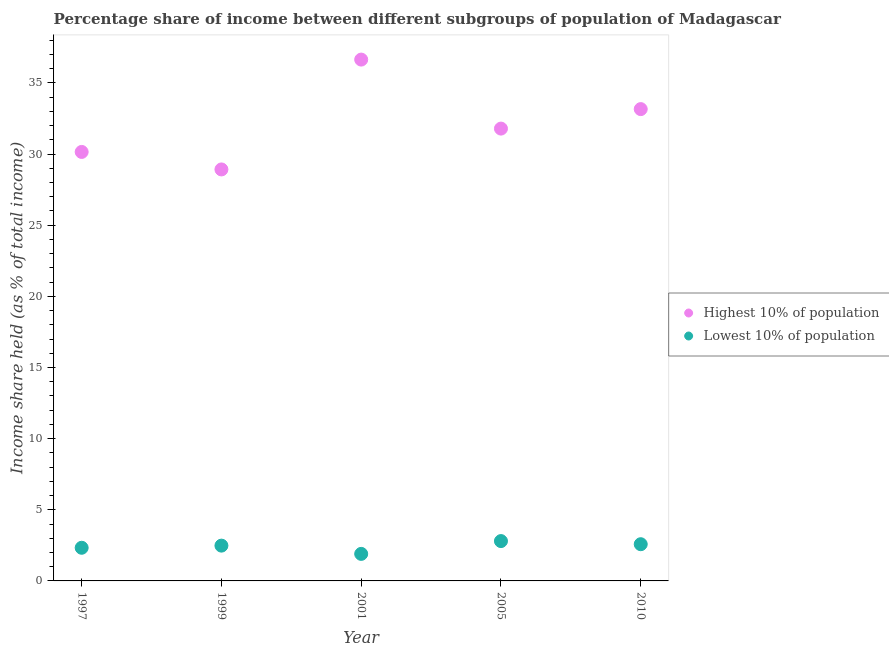What is the income share held by lowest 10% of the population in 1999?
Keep it short and to the point. 2.48. Across all years, what is the maximum income share held by highest 10% of the population?
Give a very brief answer. 36.64. Across all years, what is the minimum income share held by lowest 10% of the population?
Offer a terse response. 1.9. What is the total income share held by highest 10% of the population in the graph?
Give a very brief answer. 160.66. What is the difference between the income share held by highest 10% of the population in 2001 and that in 2005?
Give a very brief answer. 4.85. What is the difference between the income share held by lowest 10% of the population in 1997 and the income share held by highest 10% of the population in 2005?
Offer a terse response. -29.46. What is the average income share held by highest 10% of the population per year?
Provide a succinct answer. 32.13. In the year 1999, what is the difference between the income share held by highest 10% of the population and income share held by lowest 10% of the population?
Provide a short and direct response. 26.44. In how many years, is the income share held by highest 10% of the population greater than 32 %?
Your answer should be compact. 2. What is the ratio of the income share held by lowest 10% of the population in 1999 to that in 2010?
Your answer should be compact. 0.96. Is the income share held by highest 10% of the population in 1997 less than that in 2005?
Your answer should be very brief. Yes. What is the difference between the highest and the second highest income share held by highest 10% of the population?
Your answer should be compact. 3.48. What is the difference between the highest and the lowest income share held by highest 10% of the population?
Offer a very short reply. 7.72. Is the sum of the income share held by lowest 10% of the population in 1999 and 2005 greater than the maximum income share held by highest 10% of the population across all years?
Provide a short and direct response. No. Is the income share held by lowest 10% of the population strictly less than the income share held by highest 10% of the population over the years?
Provide a short and direct response. Yes. How many dotlines are there?
Provide a short and direct response. 2. What is the difference between two consecutive major ticks on the Y-axis?
Make the answer very short. 5. Are the values on the major ticks of Y-axis written in scientific E-notation?
Your answer should be very brief. No. Does the graph contain any zero values?
Give a very brief answer. No. How many legend labels are there?
Provide a short and direct response. 2. How are the legend labels stacked?
Provide a short and direct response. Vertical. What is the title of the graph?
Provide a short and direct response. Percentage share of income between different subgroups of population of Madagascar. Does "Official aid received" appear as one of the legend labels in the graph?
Provide a succinct answer. No. What is the label or title of the Y-axis?
Your answer should be compact. Income share held (as % of total income). What is the Income share held (as % of total income) of Highest 10% of population in 1997?
Keep it short and to the point. 30.15. What is the Income share held (as % of total income) of Lowest 10% of population in 1997?
Make the answer very short. 2.33. What is the Income share held (as % of total income) of Highest 10% of population in 1999?
Give a very brief answer. 28.92. What is the Income share held (as % of total income) in Lowest 10% of population in 1999?
Ensure brevity in your answer.  2.48. What is the Income share held (as % of total income) of Highest 10% of population in 2001?
Give a very brief answer. 36.64. What is the Income share held (as % of total income) in Highest 10% of population in 2005?
Offer a terse response. 31.79. What is the Income share held (as % of total income) of Highest 10% of population in 2010?
Give a very brief answer. 33.16. What is the Income share held (as % of total income) in Lowest 10% of population in 2010?
Your response must be concise. 2.58. Across all years, what is the maximum Income share held (as % of total income) of Highest 10% of population?
Offer a very short reply. 36.64. Across all years, what is the minimum Income share held (as % of total income) of Highest 10% of population?
Provide a short and direct response. 28.92. What is the total Income share held (as % of total income) in Highest 10% of population in the graph?
Your response must be concise. 160.66. What is the total Income share held (as % of total income) in Lowest 10% of population in the graph?
Ensure brevity in your answer.  12.09. What is the difference between the Income share held (as % of total income) in Highest 10% of population in 1997 and that in 1999?
Make the answer very short. 1.23. What is the difference between the Income share held (as % of total income) of Highest 10% of population in 1997 and that in 2001?
Keep it short and to the point. -6.49. What is the difference between the Income share held (as % of total income) in Lowest 10% of population in 1997 and that in 2001?
Your response must be concise. 0.43. What is the difference between the Income share held (as % of total income) of Highest 10% of population in 1997 and that in 2005?
Ensure brevity in your answer.  -1.64. What is the difference between the Income share held (as % of total income) of Lowest 10% of population in 1997 and that in 2005?
Offer a terse response. -0.47. What is the difference between the Income share held (as % of total income) in Highest 10% of population in 1997 and that in 2010?
Make the answer very short. -3.01. What is the difference between the Income share held (as % of total income) in Lowest 10% of population in 1997 and that in 2010?
Offer a very short reply. -0.25. What is the difference between the Income share held (as % of total income) of Highest 10% of population in 1999 and that in 2001?
Give a very brief answer. -7.72. What is the difference between the Income share held (as % of total income) of Lowest 10% of population in 1999 and that in 2001?
Keep it short and to the point. 0.58. What is the difference between the Income share held (as % of total income) of Highest 10% of population in 1999 and that in 2005?
Provide a succinct answer. -2.87. What is the difference between the Income share held (as % of total income) of Lowest 10% of population in 1999 and that in 2005?
Offer a very short reply. -0.32. What is the difference between the Income share held (as % of total income) in Highest 10% of population in 1999 and that in 2010?
Your answer should be very brief. -4.24. What is the difference between the Income share held (as % of total income) of Lowest 10% of population in 1999 and that in 2010?
Give a very brief answer. -0.1. What is the difference between the Income share held (as % of total income) of Highest 10% of population in 2001 and that in 2005?
Provide a short and direct response. 4.85. What is the difference between the Income share held (as % of total income) in Highest 10% of population in 2001 and that in 2010?
Offer a very short reply. 3.48. What is the difference between the Income share held (as % of total income) in Lowest 10% of population in 2001 and that in 2010?
Offer a very short reply. -0.68. What is the difference between the Income share held (as % of total income) of Highest 10% of population in 2005 and that in 2010?
Your answer should be very brief. -1.37. What is the difference between the Income share held (as % of total income) in Lowest 10% of population in 2005 and that in 2010?
Your answer should be compact. 0.22. What is the difference between the Income share held (as % of total income) in Highest 10% of population in 1997 and the Income share held (as % of total income) in Lowest 10% of population in 1999?
Offer a terse response. 27.67. What is the difference between the Income share held (as % of total income) of Highest 10% of population in 1997 and the Income share held (as % of total income) of Lowest 10% of population in 2001?
Give a very brief answer. 28.25. What is the difference between the Income share held (as % of total income) in Highest 10% of population in 1997 and the Income share held (as % of total income) in Lowest 10% of population in 2005?
Make the answer very short. 27.35. What is the difference between the Income share held (as % of total income) in Highest 10% of population in 1997 and the Income share held (as % of total income) in Lowest 10% of population in 2010?
Give a very brief answer. 27.57. What is the difference between the Income share held (as % of total income) of Highest 10% of population in 1999 and the Income share held (as % of total income) of Lowest 10% of population in 2001?
Ensure brevity in your answer.  27.02. What is the difference between the Income share held (as % of total income) of Highest 10% of population in 1999 and the Income share held (as % of total income) of Lowest 10% of population in 2005?
Give a very brief answer. 26.12. What is the difference between the Income share held (as % of total income) in Highest 10% of population in 1999 and the Income share held (as % of total income) in Lowest 10% of population in 2010?
Provide a succinct answer. 26.34. What is the difference between the Income share held (as % of total income) of Highest 10% of population in 2001 and the Income share held (as % of total income) of Lowest 10% of population in 2005?
Give a very brief answer. 33.84. What is the difference between the Income share held (as % of total income) in Highest 10% of population in 2001 and the Income share held (as % of total income) in Lowest 10% of population in 2010?
Offer a very short reply. 34.06. What is the difference between the Income share held (as % of total income) in Highest 10% of population in 2005 and the Income share held (as % of total income) in Lowest 10% of population in 2010?
Make the answer very short. 29.21. What is the average Income share held (as % of total income) in Highest 10% of population per year?
Provide a short and direct response. 32.13. What is the average Income share held (as % of total income) of Lowest 10% of population per year?
Your response must be concise. 2.42. In the year 1997, what is the difference between the Income share held (as % of total income) in Highest 10% of population and Income share held (as % of total income) in Lowest 10% of population?
Give a very brief answer. 27.82. In the year 1999, what is the difference between the Income share held (as % of total income) of Highest 10% of population and Income share held (as % of total income) of Lowest 10% of population?
Your answer should be compact. 26.44. In the year 2001, what is the difference between the Income share held (as % of total income) in Highest 10% of population and Income share held (as % of total income) in Lowest 10% of population?
Give a very brief answer. 34.74. In the year 2005, what is the difference between the Income share held (as % of total income) of Highest 10% of population and Income share held (as % of total income) of Lowest 10% of population?
Provide a short and direct response. 28.99. In the year 2010, what is the difference between the Income share held (as % of total income) in Highest 10% of population and Income share held (as % of total income) in Lowest 10% of population?
Your answer should be compact. 30.58. What is the ratio of the Income share held (as % of total income) in Highest 10% of population in 1997 to that in 1999?
Offer a very short reply. 1.04. What is the ratio of the Income share held (as % of total income) of Lowest 10% of population in 1997 to that in 1999?
Your answer should be very brief. 0.94. What is the ratio of the Income share held (as % of total income) in Highest 10% of population in 1997 to that in 2001?
Provide a short and direct response. 0.82. What is the ratio of the Income share held (as % of total income) of Lowest 10% of population in 1997 to that in 2001?
Provide a short and direct response. 1.23. What is the ratio of the Income share held (as % of total income) of Highest 10% of population in 1997 to that in 2005?
Your answer should be very brief. 0.95. What is the ratio of the Income share held (as % of total income) of Lowest 10% of population in 1997 to that in 2005?
Offer a very short reply. 0.83. What is the ratio of the Income share held (as % of total income) of Highest 10% of population in 1997 to that in 2010?
Provide a succinct answer. 0.91. What is the ratio of the Income share held (as % of total income) of Lowest 10% of population in 1997 to that in 2010?
Give a very brief answer. 0.9. What is the ratio of the Income share held (as % of total income) in Highest 10% of population in 1999 to that in 2001?
Offer a terse response. 0.79. What is the ratio of the Income share held (as % of total income) in Lowest 10% of population in 1999 to that in 2001?
Ensure brevity in your answer.  1.31. What is the ratio of the Income share held (as % of total income) in Highest 10% of population in 1999 to that in 2005?
Your answer should be very brief. 0.91. What is the ratio of the Income share held (as % of total income) in Lowest 10% of population in 1999 to that in 2005?
Provide a succinct answer. 0.89. What is the ratio of the Income share held (as % of total income) in Highest 10% of population in 1999 to that in 2010?
Give a very brief answer. 0.87. What is the ratio of the Income share held (as % of total income) in Lowest 10% of population in 1999 to that in 2010?
Offer a terse response. 0.96. What is the ratio of the Income share held (as % of total income) of Highest 10% of population in 2001 to that in 2005?
Give a very brief answer. 1.15. What is the ratio of the Income share held (as % of total income) in Lowest 10% of population in 2001 to that in 2005?
Keep it short and to the point. 0.68. What is the ratio of the Income share held (as % of total income) in Highest 10% of population in 2001 to that in 2010?
Provide a succinct answer. 1.1. What is the ratio of the Income share held (as % of total income) of Lowest 10% of population in 2001 to that in 2010?
Keep it short and to the point. 0.74. What is the ratio of the Income share held (as % of total income) of Highest 10% of population in 2005 to that in 2010?
Offer a very short reply. 0.96. What is the ratio of the Income share held (as % of total income) in Lowest 10% of population in 2005 to that in 2010?
Your response must be concise. 1.09. What is the difference between the highest and the second highest Income share held (as % of total income) of Highest 10% of population?
Keep it short and to the point. 3.48. What is the difference between the highest and the second highest Income share held (as % of total income) in Lowest 10% of population?
Provide a short and direct response. 0.22. What is the difference between the highest and the lowest Income share held (as % of total income) of Highest 10% of population?
Your response must be concise. 7.72. 